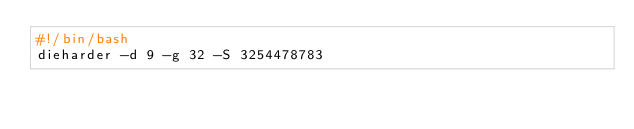<code> <loc_0><loc_0><loc_500><loc_500><_Bash_>#!/bin/bash
dieharder -d 9 -g 32 -S 3254478783
</code> 